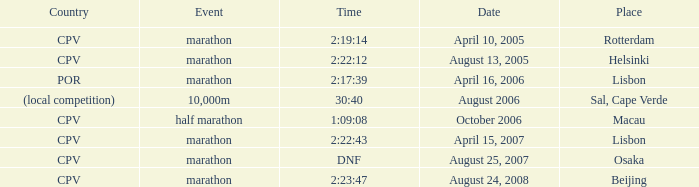What is the Country of the Half Marathon Event? CPV. 